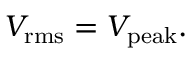Convert formula to latex. <formula><loc_0><loc_0><loc_500><loc_500>V _ { r m s } = V _ { p e a k } .</formula> 